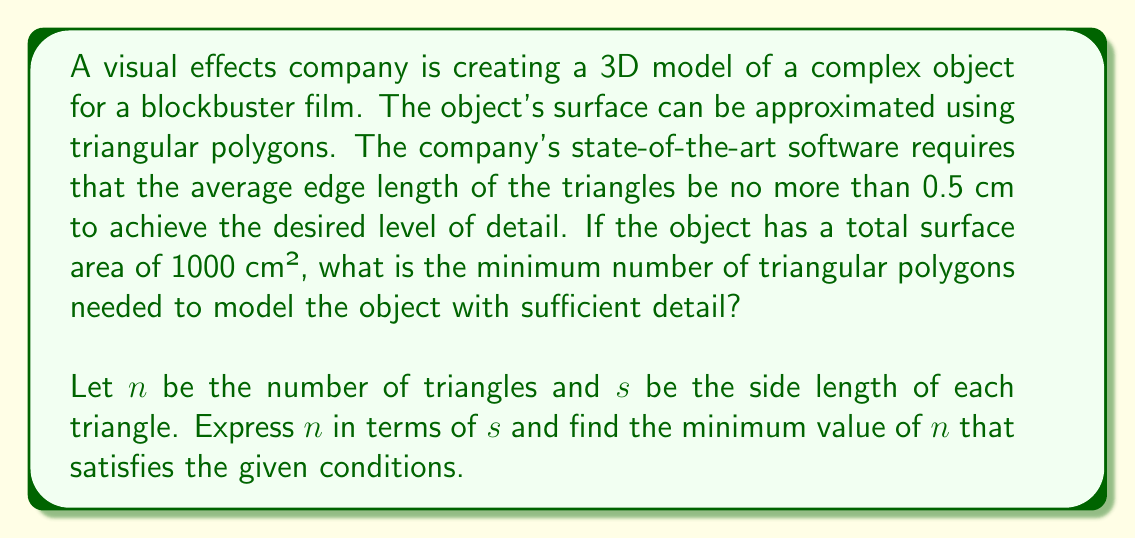Give your solution to this math problem. To solve this problem, we need to follow these steps:

1) First, let's express the total surface area in terms of $n$ and $s$:
   Total Area = $n \cdot$ Area of one triangle
   $1000 = n \cdot \frac{\sqrt{3}}{4}s^2$

2) We can rearrange this to express $n$ in terms of $s$:
   $n = \frac{4000}{\sqrt{3}s^2}$

3) Now, we need to consider the condition that the average edge length should be no more than 0.5 cm. This means:
   $s \leq 0.5$

4) To find the minimum number of triangles, we need to use the maximum allowed value of $s$, which is 0.5 cm.

5) Substituting $s = 0.5$ into our equation for $n$:
   $n = \frac{4000}{\sqrt{3}(0.5)^2} = \frac{16000}{\sqrt{3}}$

6) Calculating this:
   $n \approx 9238.58$

7) Since we can't have a fractional number of triangles, we need to round up to the nearest whole number.

Therefore, the minimum number of triangular polygons needed is 9239.
Answer: The minimum number of triangular polygons needed is 9239. 